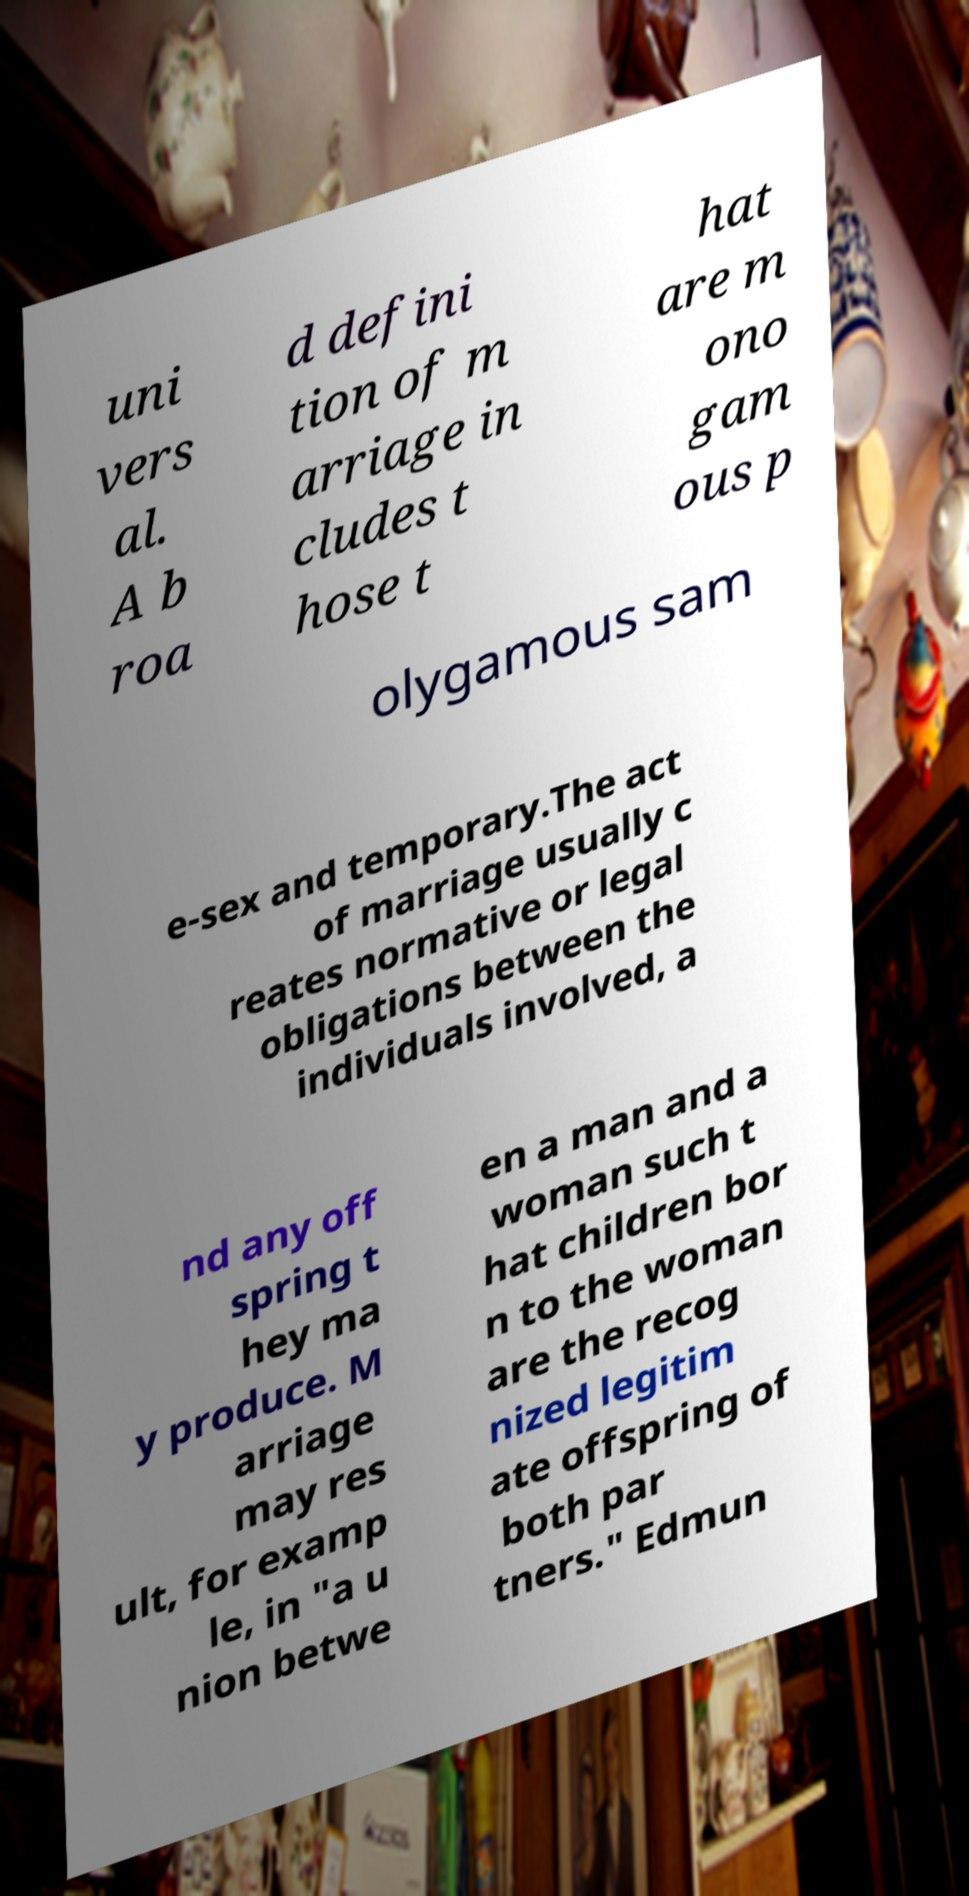There's text embedded in this image that I need extracted. Can you transcribe it verbatim? uni vers al. A b roa d defini tion of m arriage in cludes t hose t hat are m ono gam ous p olygamous sam e-sex and temporary.The act of marriage usually c reates normative or legal obligations between the individuals involved, a nd any off spring t hey ma y produce. M arriage may res ult, for examp le, in "a u nion betwe en a man and a woman such t hat children bor n to the woman are the recog nized legitim ate offspring of both par tners." Edmun 